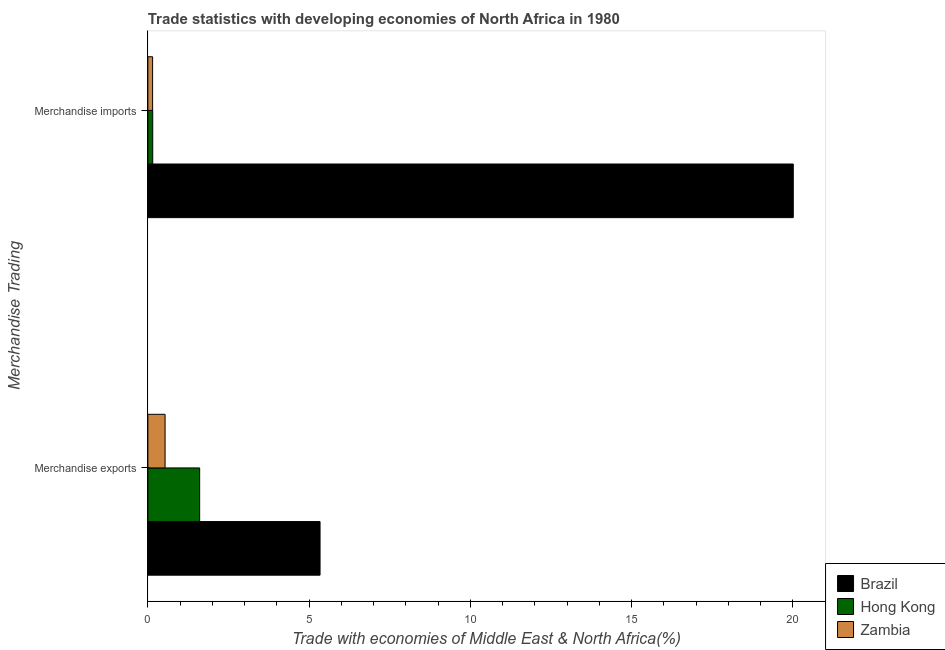Are the number of bars on each tick of the Y-axis equal?
Provide a short and direct response. Yes. What is the merchandise exports in Brazil?
Offer a very short reply. 5.34. Across all countries, what is the maximum merchandise exports?
Provide a short and direct response. 5.34. Across all countries, what is the minimum merchandise imports?
Offer a very short reply. 0.15. In which country was the merchandise exports maximum?
Keep it short and to the point. Brazil. In which country was the merchandise exports minimum?
Your answer should be compact. Zambia. What is the total merchandise imports in the graph?
Keep it short and to the point. 20.31. What is the difference between the merchandise exports in Brazil and that in Hong Kong?
Ensure brevity in your answer.  3.73. What is the difference between the merchandise imports in Zambia and the merchandise exports in Brazil?
Offer a terse response. -5.19. What is the average merchandise exports per country?
Offer a terse response. 2.49. What is the difference between the merchandise exports and merchandise imports in Hong Kong?
Give a very brief answer. 1.45. In how many countries, is the merchandise exports greater than 1 %?
Offer a terse response. 2. What is the ratio of the merchandise exports in Zambia to that in Hong Kong?
Your response must be concise. 0.33. Is the merchandise imports in Hong Kong less than that in Brazil?
Provide a short and direct response. Yes. In how many countries, is the merchandise exports greater than the average merchandise exports taken over all countries?
Provide a succinct answer. 1. What does the 2nd bar from the bottom in Merchandise exports represents?
Provide a succinct answer. Hong Kong. Are the values on the major ticks of X-axis written in scientific E-notation?
Give a very brief answer. No. Does the graph contain any zero values?
Ensure brevity in your answer.  No. Where does the legend appear in the graph?
Provide a succinct answer. Bottom right. How many legend labels are there?
Make the answer very short. 3. How are the legend labels stacked?
Ensure brevity in your answer.  Vertical. What is the title of the graph?
Offer a very short reply. Trade statistics with developing economies of North Africa in 1980. What is the label or title of the X-axis?
Offer a very short reply. Trade with economies of Middle East & North Africa(%). What is the label or title of the Y-axis?
Make the answer very short. Merchandise Trading. What is the Trade with economies of Middle East & North Africa(%) in Brazil in Merchandise exports?
Offer a terse response. 5.34. What is the Trade with economies of Middle East & North Africa(%) of Hong Kong in Merchandise exports?
Ensure brevity in your answer.  1.61. What is the Trade with economies of Middle East & North Africa(%) in Zambia in Merchandise exports?
Keep it short and to the point. 0.53. What is the Trade with economies of Middle East & North Africa(%) of Brazil in Merchandise imports?
Keep it short and to the point. 20.01. What is the Trade with economies of Middle East & North Africa(%) of Hong Kong in Merchandise imports?
Give a very brief answer. 0.15. What is the Trade with economies of Middle East & North Africa(%) of Zambia in Merchandise imports?
Provide a short and direct response. 0.15. Across all Merchandise Trading, what is the maximum Trade with economies of Middle East & North Africa(%) of Brazil?
Provide a short and direct response. 20.01. Across all Merchandise Trading, what is the maximum Trade with economies of Middle East & North Africa(%) of Hong Kong?
Provide a succinct answer. 1.61. Across all Merchandise Trading, what is the maximum Trade with economies of Middle East & North Africa(%) of Zambia?
Ensure brevity in your answer.  0.53. Across all Merchandise Trading, what is the minimum Trade with economies of Middle East & North Africa(%) in Brazil?
Make the answer very short. 5.34. Across all Merchandise Trading, what is the minimum Trade with economies of Middle East & North Africa(%) of Hong Kong?
Provide a succinct answer. 0.15. Across all Merchandise Trading, what is the minimum Trade with economies of Middle East & North Africa(%) of Zambia?
Your answer should be compact. 0.15. What is the total Trade with economies of Middle East & North Africa(%) of Brazil in the graph?
Offer a very short reply. 25.35. What is the total Trade with economies of Middle East & North Africa(%) of Hong Kong in the graph?
Keep it short and to the point. 1.76. What is the total Trade with economies of Middle East & North Africa(%) in Zambia in the graph?
Give a very brief answer. 0.68. What is the difference between the Trade with economies of Middle East & North Africa(%) of Brazil in Merchandise exports and that in Merchandise imports?
Your answer should be compact. -14.68. What is the difference between the Trade with economies of Middle East & North Africa(%) of Hong Kong in Merchandise exports and that in Merchandise imports?
Provide a succinct answer. 1.45. What is the difference between the Trade with economies of Middle East & North Africa(%) in Zambia in Merchandise exports and that in Merchandise imports?
Offer a terse response. 0.39. What is the difference between the Trade with economies of Middle East & North Africa(%) of Brazil in Merchandise exports and the Trade with economies of Middle East & North Africa(%) of Hong Kong in Merchandise imports?
Offer a very short reply. 5.19. What is the difference between the Trade with economies of Middle East & North Africa(%) in Brazil in Merchandise exports and the Trade with economies of Middle East & North Africa(%) in Zambia in Merchandise imports?
Your answer should be compact. 5.19. What is the difference between the Trade with economies of Middle East & North Africa(%) in Hong Kong in Merchandise exports and the Trade with economies of Middle East & North Africa(%) in Zambia in Merchandise imports?
Ensure brevity in your answer.  1.46. What is the average Trade with economies of Middle East & North Africa(%) in Brazil per Merchandise Trading?
Make the answer very short. 12.68. What is the average Trade with economies of Middle East & North Africa(%) in Hong Kong per Merchandise Trading?
Give a very brief answer. 0.88. What is the average Trade with economies of Middle East & North Africa(%) in Zambia per Merchandise Trading?
Ensure brevity in your answer.  0.34. What is the difference between the Trade with economies of Middle East & North Africa(%) in Brazil and Trade with economies of Middle East & North Africa(%) in Hong Kong in Merchandise exports?
Give a very brief answer. 3.73. What is the difference between the Trade with economies of Middle East & North Africa(%) in Brazil and Trade with economies of Middle East & North Africa(%) in Zambia in Merchandise exports?
Your answer should be compact. 4.81. What is the difference between the Trade with economies of Middle East & North Africa(%) of Hong Kong and Trade with economies of Middle East & North Africa(%) of Zambia in Merchandise exports?
Your answer should be very brief. 1.07. What is the difference between the Trade with economies of Middle East & North Africa(%) in Brazil and Trade with economies of Middle East & North Africa(%) in Hong Kong in Merchandise imports?
Give a very brief answer. 19.86. What is the difference between the Trade with economies of Middle East & North Africa(%) in Brazil and Trade with economies of Middle East & North Africa(%) in Zambia in Merchandise imports?
Keep it short and to the point. 19.87. What is the difference between the Trade with economies of Middle East & North Africa(%) in Hong Kong and Trade with economies of Middle East & North Africa(%) in Zambia in Merchandise imports?
Keep it short and to the point. 0. What is the ratio of the Trade with economies of Middle East & North Africa(%) of Brazil in Merchandise exports to that in Merchandise imports?
Offer a very short reply. 0.27. What is the ratio of the Trade with economies of Middle East & North Africa(%) of Hong Kong in Merchandise exports to that in Merchandise imports?
Your response must be concise. 10.64. What is the ratio of the Trade with economies of Middle East & North Africa(%) in Zambia in Merchandise exports to that in Merchandise imports?
Your answer should be compact. 3.63. What is the difference between the highest and the second highest Trade with economies of Middle East & North Africa(%) in Brazil?
Give a very brief answer. 14.68. What is the difference between the highest and the second highest Trade with economies of Middle East & North Africa(%) in Hong Kong?
Provide a short and direct response. 1.45. What is the difference between the highest and the second highest Trade with economies of Middle East & North Africa(%) of Zambia?
Make the answer very short. 0.39. What is the difference between the highest and the lowest Trade with economies of Middle East & North Africa(%) in Brazil?
Make the answer very short. 14.68. What is the difference between the highest and the lowest Trade with economies of Middle East & North Africa(%) in Hong Kong?
Ensure brevity in your answer.  1.45. What is the difference between the highest and the lowest Trade with economies of Middle East & North Africa(%) in Zambia?
Your answer should be very brief. 0.39. 